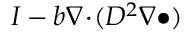Convert formula to latex. <formula><loc_0><loc_0><loc_500><loc_500>I - b \nabla \, \cdot \, ( D ^ { 2 } \nabla \bullet )</formula> 